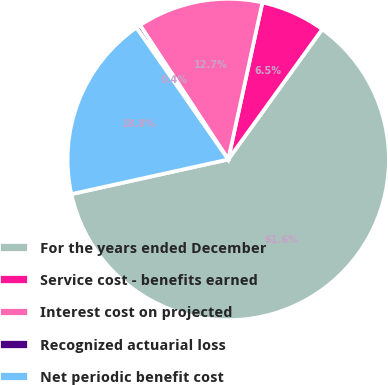Convert chart. <chart><loc_0><loc_0><loc_500><loc_500><pie_chart><fcel>For the years ended December<fcel>Service cost - benefits earned<fcel>Interest cost on projected<fcel>Recognized actuarial loss<fcel>Net periodic benefit cost<nl><fcel>61.59%<fcel>6.54%<fcel>12.66%<fcel>0.43%<fcel>18.78%<nl></chart> 